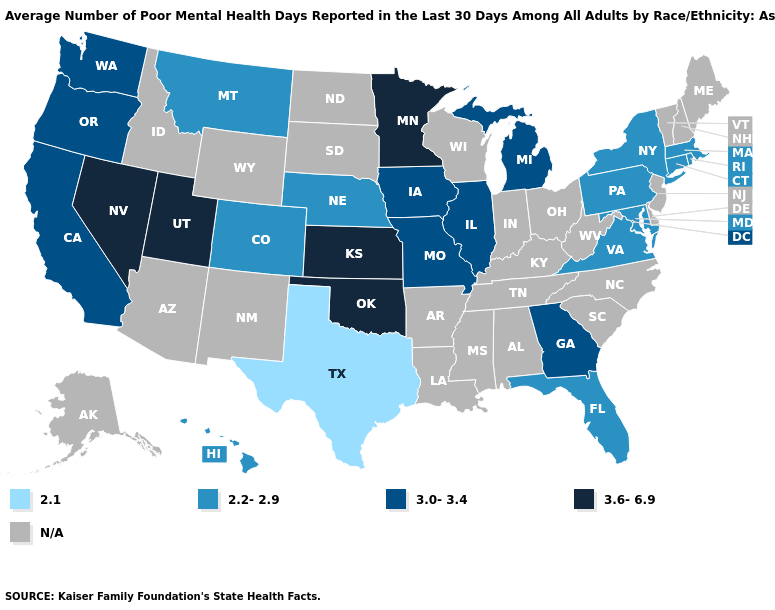Name the states that have a value in the range 3.6-6.9?
Write a very short answer. Kansas, Minnesota, Nevada, Oklahoma, Utah. Does Montana have the lowest value in the West?
Short answer required. Yes. Name the states that have a value in the range 3.0-3.4?
Give a very brief answer. California, Georgia, Illinois, Iowa, Michigan, Missouri, Oregon, Washington. Name the states that have a value in the range 3.0-3.4?
Keep it brief. California, Georgia, Illinois, Iowa, Michigan, Missouri, Oregon, Washington. What is the value of Colorado?
Concise answer only. 2.2-2.9. What is the highest value in states that border Oregon?
Short answer required. 3.6-6.9. What is the value of Nevada?
Answer briefly. 3.6-6.9. Among the states that border Nevada , does Utah have the lowest value?
Give a very brief answer. No. What is the value of Minnesota?
Answer briefly. 3.6-6.9. Which states have the highest value in the USA?
Give a very brief answer. Kansas, Minnesota, Nevada, Oklahoma, Utah. Which states hav the highest value in the West?
Give a very brief answer. Nevada, Utah. Name the states that have a value in the range 2.2-2.9?
Keep it brief. Colorado, Connecticut, Florida, Hawaii, Maryland, Massachusetts, Montana, Nebraska, New York, Pennsylvania, Rhode Island, Virginia. What is the value of Wisconsin?
Give a very brief answer. N/A. What is the value of Iowa?
Short answer required. 3.0-3.4. 